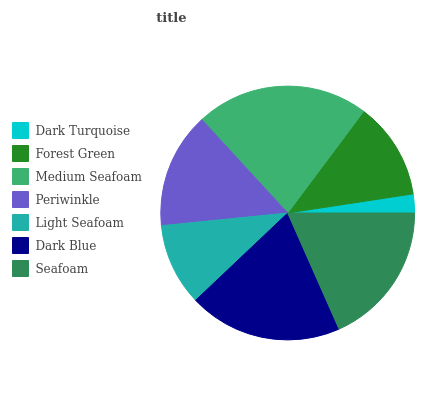Is Dark Turquoise the minimum?
Answer yes or no. Yes. Is Medium Seafoam the maximum?
Answer yes or no. Yes. Is Forest Green the minimum?
Answer yes or no. No. Is Forest Green the maximum?
Answer yes or no. No. Is Forest Green greater than Dark Turquoise?
Answer yes or no. Yes. Is Dark Turquoise less than Forest Green?
Answer yes or no. Yes. Is Dark Turquoise greater than Forest Green?
Answer yes or no. No. Is Forest Green less than Dark Turquoise?
Answer yes or no. No. Is Periwinkle the high median?
Answer yes or no. Yes. Is Periwinkle the low median?
Answer yes or no. Yes. Is Forest Green the high median?
Answer yes or no. No. Is Seafoam the low median?
Answer yes or no. No. 